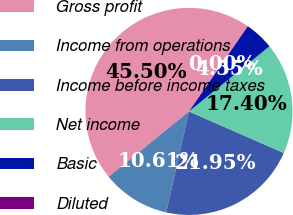<chart> <loc_0><loc_0><loc_500><loc_500><pie_chart><fcel>Gross profit<fcel>Income from operations<fcel>Income before income taxes<fcel>Net income<fcel>Basic<fcel>Diluted<nl><fcel>45.5%<fcel>10.61%<fcel>21.95%<fcel>17.4%<fcel>4.55%<fcel>0.0%<nl></chart> 